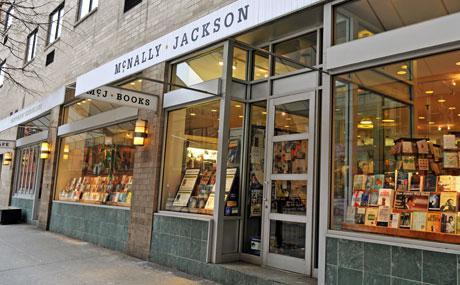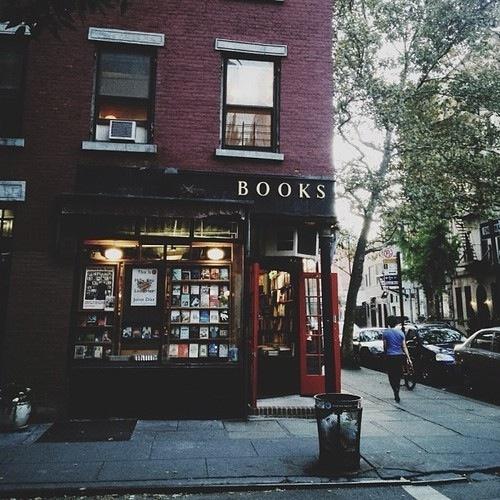The first image is the image on the left, the second image is the image on the right. Given the left and right images, does the statement "The right image shows a bookstore in the corner of a dark red brick building, with its name on black above a red door." hold true? Answer yes or no. Yes. The first image is the image on the left, the second image is the image on the right. For the images displayed, is the sentence "The door in the right image is open." factually correct? Answer yes or no. Yes. 